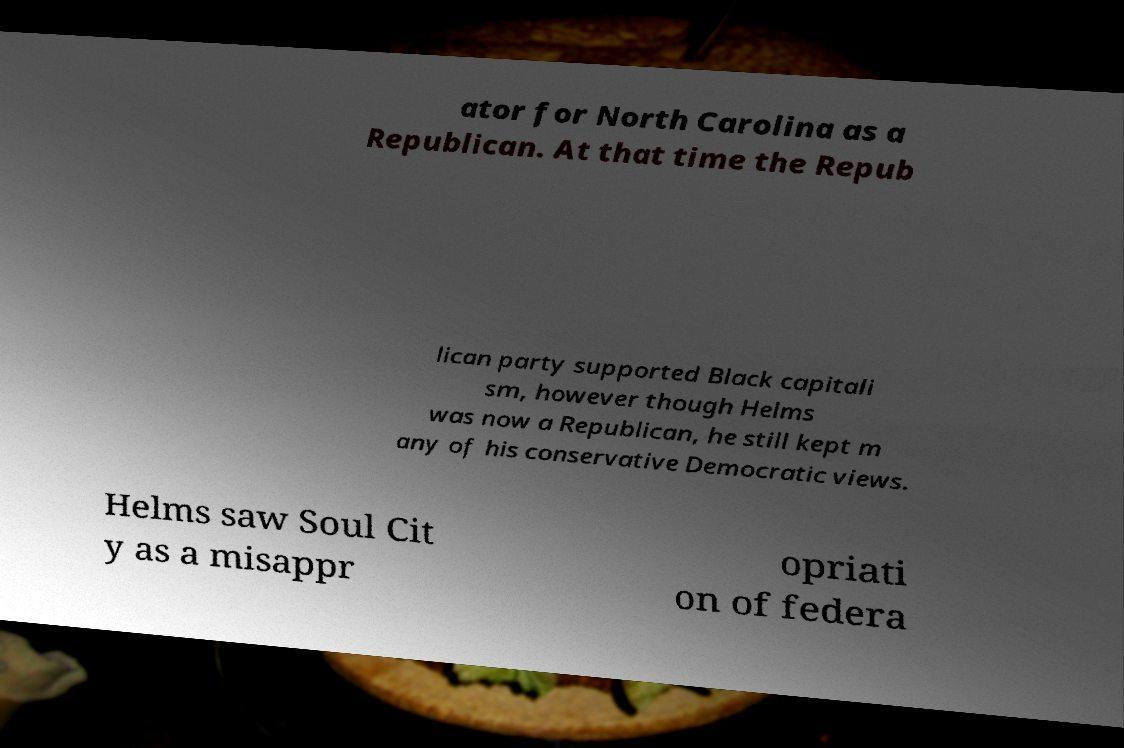Please read and relay the text visible in this image. What does it say? ator for North Carolina as a Republican. At that time the Repub lican party supported Black capitali sm, however though Helms was now a Republican, he still kept m any of his conservative Democratic views. Helms saw Soul Cit y as a misappr opriati on of federa 